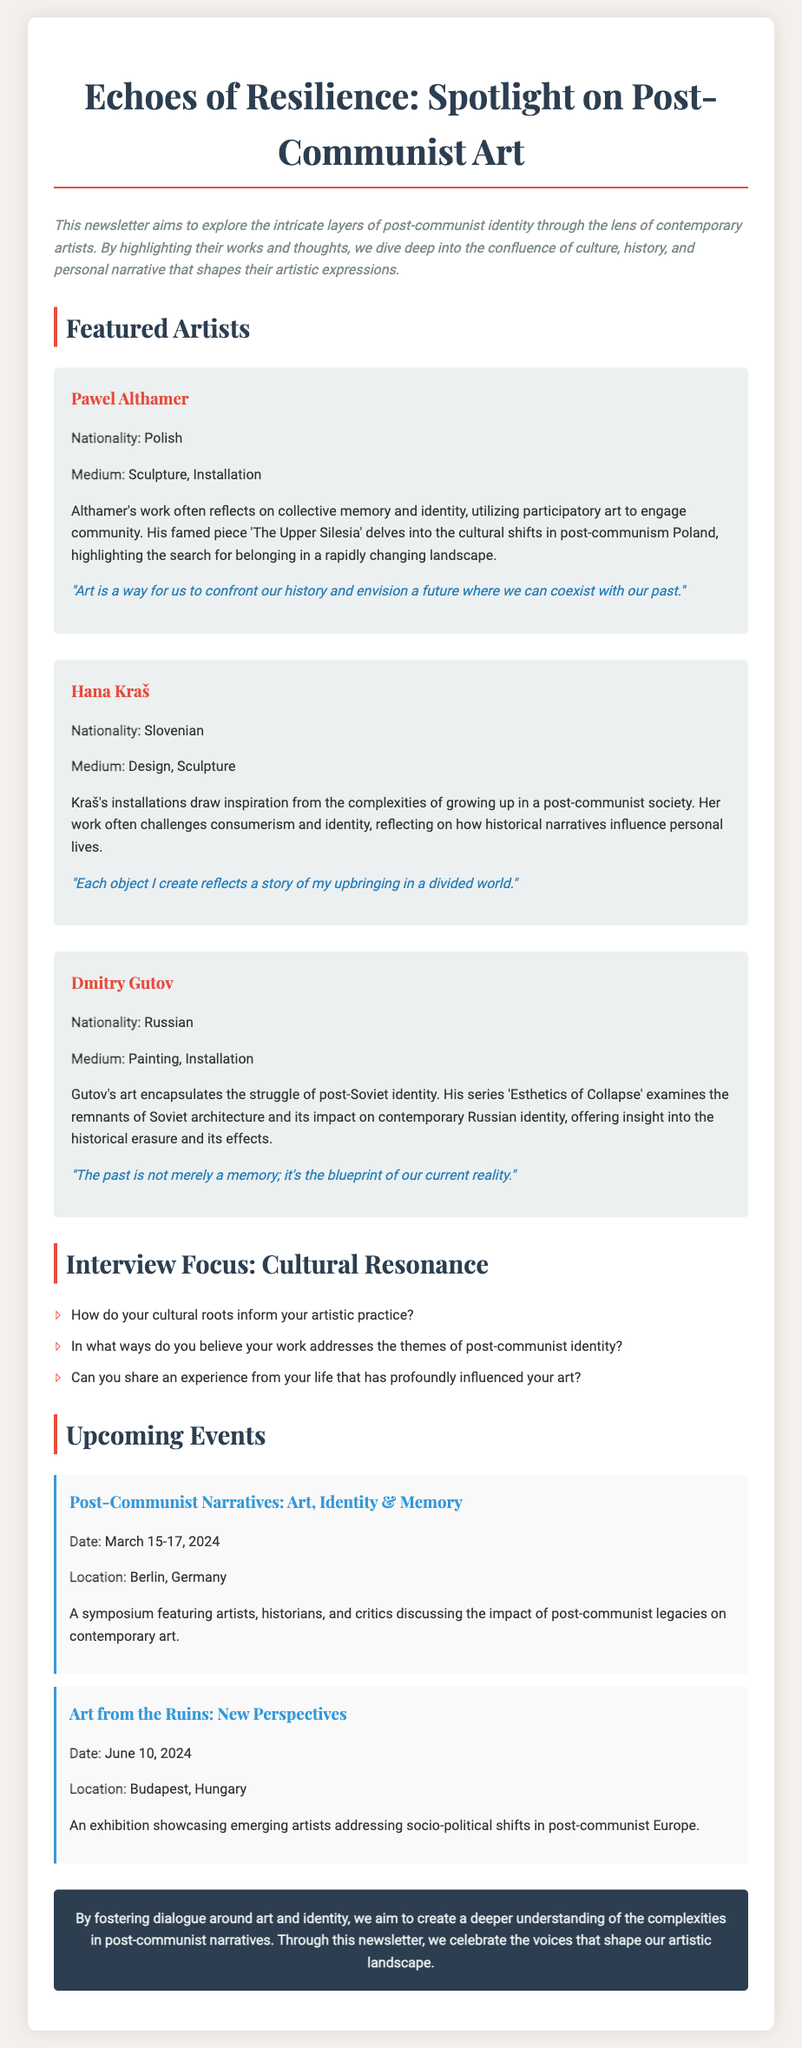What is the title of the newsletter? The title of the newsletter is stated prominently at the top of the document.
Answer: Echoes of Resilience: Spotlight on Post-Communist Art Who is the first featured artist? The first featured artist is listed in the section detailing highlighted artists.
Answer: Pawel Althamer What medium does Hana Kraš work in? The medium of Hana Kraš is mentioned in her artist spotlight.
Answer: Design, Sculpture When is the event "Post-Communist Narratives: Art, Identity & Memory" scheduled? The date of the event is provided in the upcoming events section.
Answer: March 15-17, 2024 What nationality is Dmitry Gutov? The nationality of Dmitry Gutov is specified in his artist profile.
Answer: Russian How does Pawel Althamer describe the role of art in relation to history? This is found in his quote in the artist spotlight.
Answer: confront our history and envision a future where we can coexist with our past What is the location of the exhibition "Art from the Ruins: New Perspectives"? The location for the exhibition is listed under the event details.
Answer: Budapest, Hungary What theme do the interview questions focus on? The focus of the interview questions is highlighted in the section header.
Answer: Cultural Resonance 